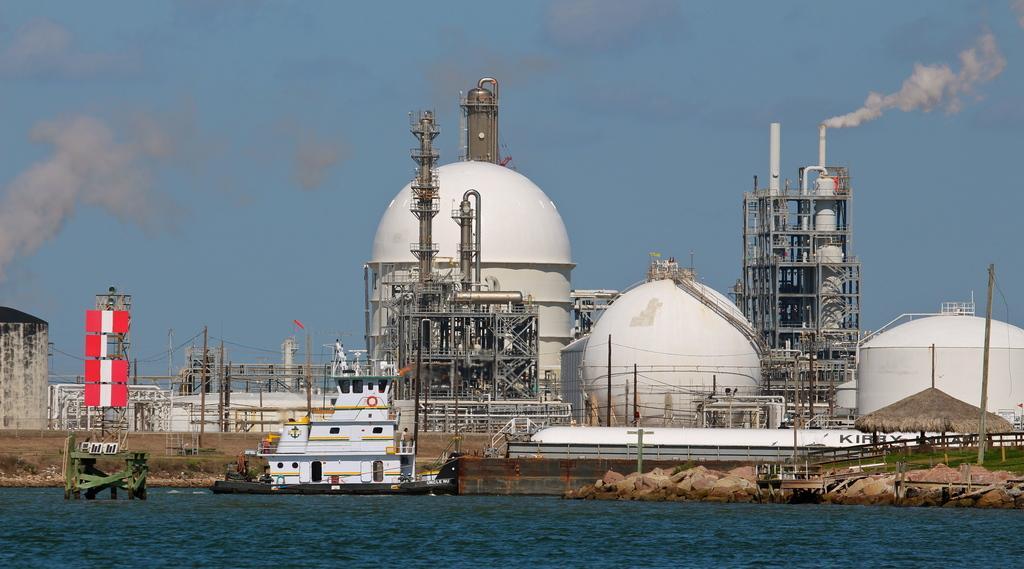Describe this image in one or two sentences. It looks like a factory, on the path there are poles with cables and a hut. Behind the factory there is smoke and the sky. In front of the factory there are objects on the water 